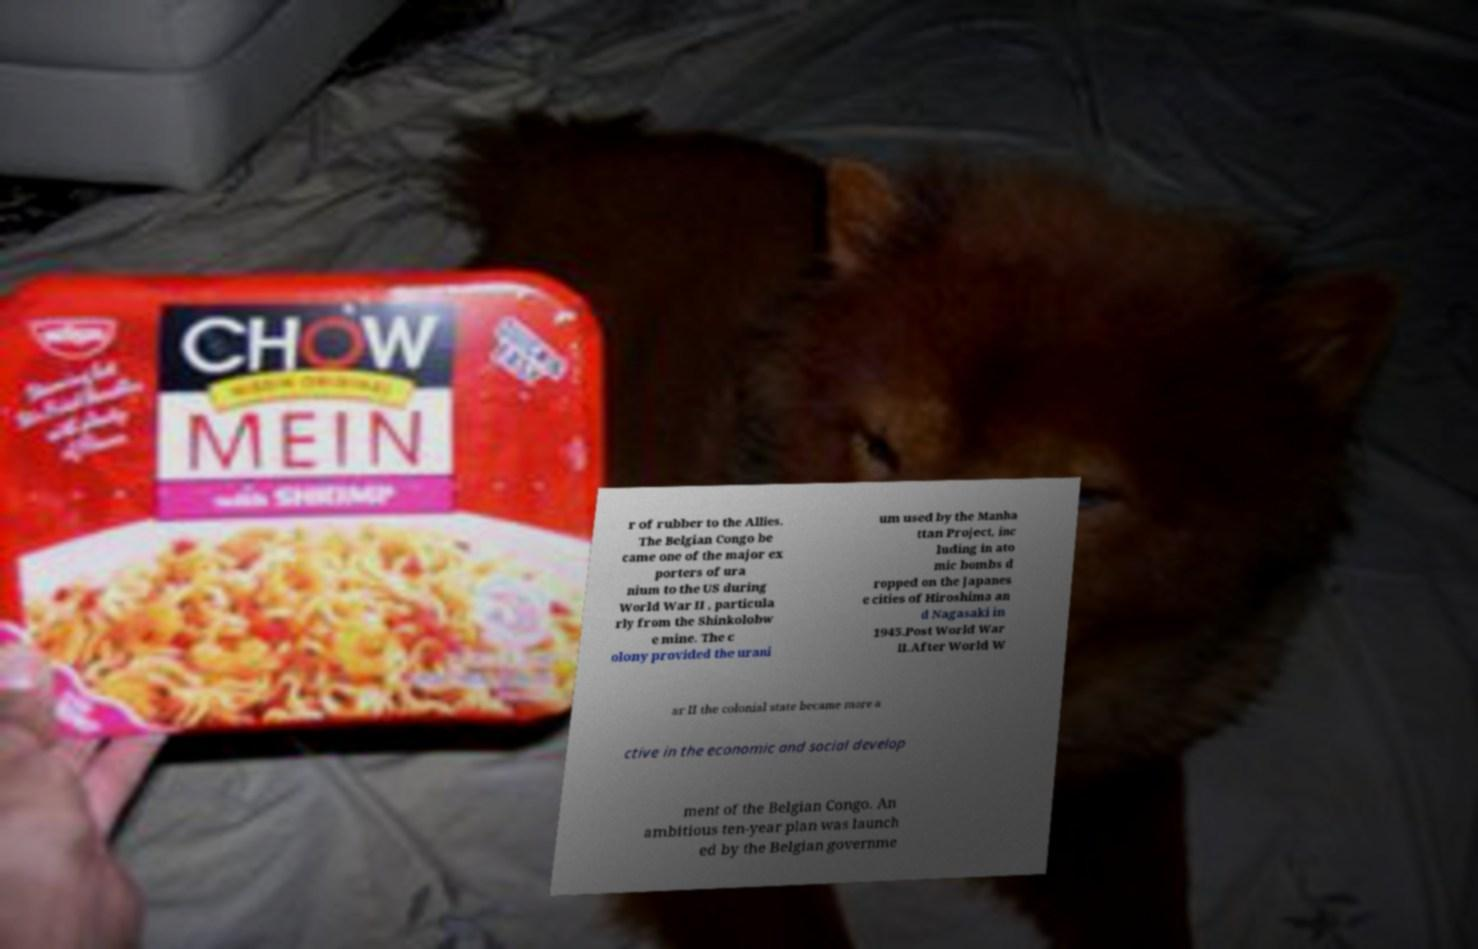Please identify and transcribe the text found in this image. r of rubber to the Allies. The Belgian Congo be came one of the major ex porters of ura nium to the US during World War II , particula rly from the Shinkolobw e mine. The c olony provided the urani um used by the Manha ttan Project, inc luding in ato mic bombs d ropped on the Japanes e cities of Hiroshima an d Nagasaki in 1945.Post World War II.After World W ar II the colonial state became more a ctive in the economic and social develop ment of the Belgian Congo. An ambitious ten-year plan was launch ed by the Belgian governme 